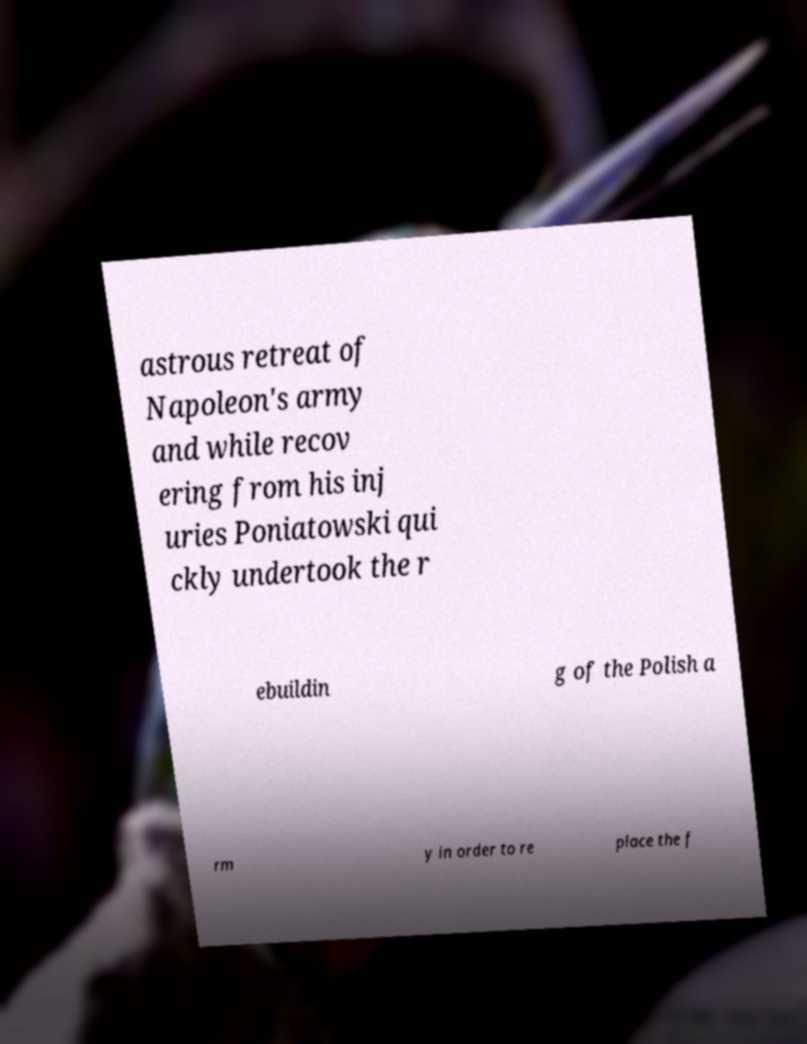Can you accurately transcribe the text from the provided image for me? astrous retreat of Napoleon's army and while recov ering from his inj uries Poniatowski qui ckly undertook the r ebuildin g of the Polish a rm y in order to re place the f 